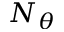<formula> <loc_0><loc_0><loc_500><loc_500>N _ { \theta }</formula> 